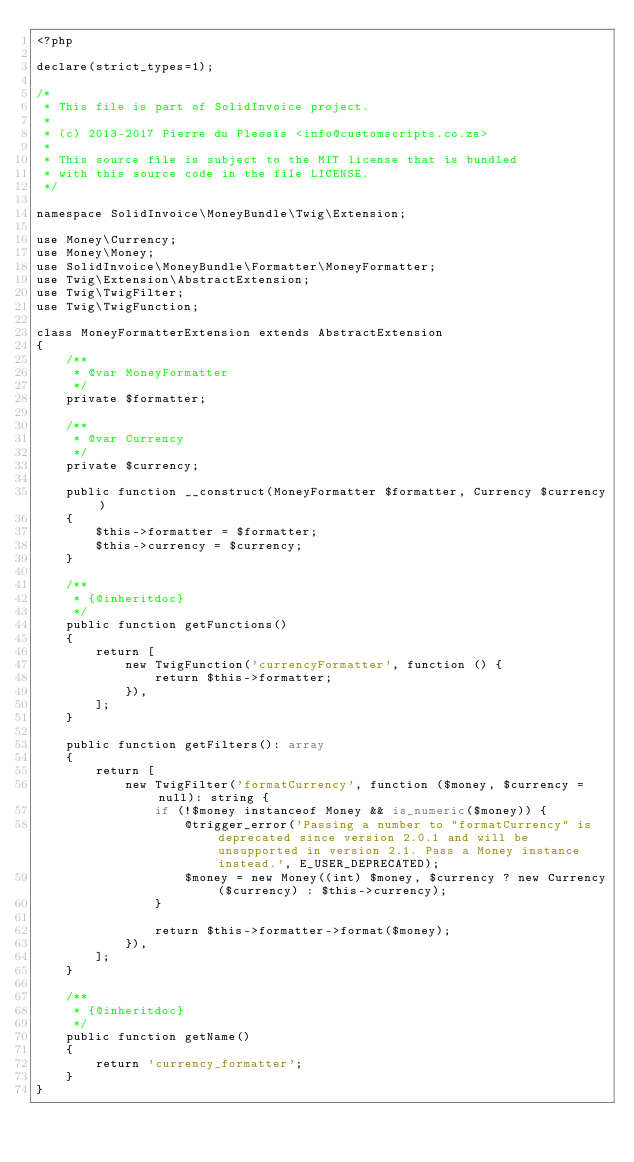Convert code to text. <code><loc_0><loc_0><loc_500><loc_500><_PHP_><?php

declare(strict_types=1);

/*
 * This file is part of SolidInvoice project.
 *
 * (c) 2013-2017 Pierre du Plessis <info@customscripts.co.za>
 *
 * This source file is subject to the MIT license that is bundled
 * with this source code in the file LICENSE.
 */

namespace SolidInvoice\MoneyBundle\Twig\Extension;

use Money\Currency;
use Money\Money;
use SolidInvoice\MoneyBundle\Formatter\MoneyFormatter;
use Twig\Extension\AbstractExtension;
use Twig\TwigFilter;
use Twig\TwigFunction;

class MoneyFormatterExtension extends AbstractExtension
{
    /**
     * @var MoneyFormatter
     */
    private $formatter;

    /**
     * @var Currency
     */
    private $currency;

    public function __construct(MoneyFormatter $formatter, Currency $currency)
    {
        $this->formatter = $formatter;
        $this->currency = $currency;
    }

    /**
     * {@inheritdoc}
     */
    public function getFunctions()
    {
        return [
            new TwigFunction('currencyFormatter', function () {
                return $this->formatter;
            }),
        ];
    }

    public function getFilters(): array
    {
        return [
            new TwigFilter('formatCurrency', function ($money, $currency = null): string {
                if (!$money instanceof Money && is_numeric($money)) {
                    @trigger_error('Passing a number to "formatCurrency" is deprecated since version 2.0.1 and will be unsupported in version 2.1. Pass a Money instance instead.', E_USER_DEPRECATED);
                    $money = new Money((int) $money, $currency ? new Currency($currency) : $this->currency);
                }

                return $this->formatter->format($money);
            }),
        ];
    }

    /**
     * {@inheritdoc}
     */
    public function getName()
    {
        return 'currency_formatter';
    }
}
</code> 